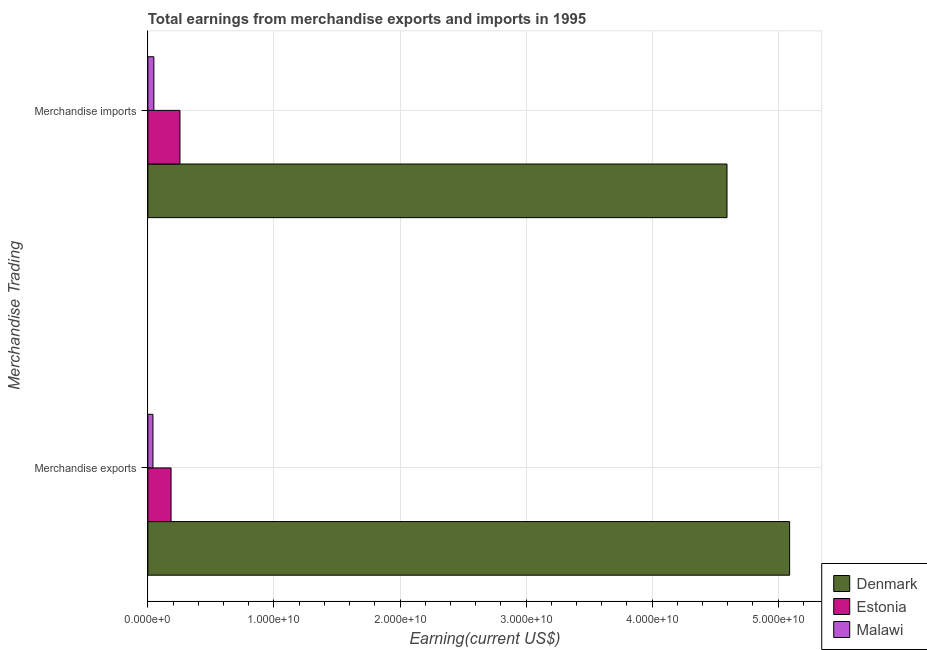How many different coloured bars are there?
Make the answer very short. 3. How many groups of bars are there?
Keep it short and to the point. 2. Are the number of bars per tick equal to the number of legend labels?
Keep it short and to the point. Yes. Are the number of bars on each tick of the Y-axis equal?
Offer a very short reply. Yes. How many bars are there on the 2nd tick from the bottom?
Offer a terse response. 3. What is the label of the 2nd group of bars from the top?
Ensure brevity in your answer.  Merchandise exports. What is the earnings from merchandise exports in Malawi?
Make the answer very short. 4.05e+08. Across all countries, what is the maximum earnings from merchandise imports?
Offer a terse response. 4.59e+1. Across all countries, what is the minimum earnings from merchandise exports?
Your response must be concise. 4.05e+08. In which country was the earnings from merchandise exports maximum?
Your answer should be compact. Denmark. In which country was the earnings from merchandise imports minimum?
Ensure brevity in your answer.  Malawi. What is the total earnings from merchandise exports in the graph?
Make the answer very short. 5.32e+1. What is the difference between the earnings from merchandise exports in Denmark and that in Estonia?
Your answer should be very brief. 4.91e+1. What is the difference between the earnings from merchandise imports in Denmark and the earnings from merchandise exports in Estonia?
Provide a short and direct response. 4.41e+1. What is the average earnings from merchandise imports per country?
Your answer should be very brief. 1.63e+1. What is the difference between the earnings from merchandise exports and earnings from merchandise imports in Estonia?
Provide a succinct answer. -7.06e+08. What is the ratio of the earnings from merchandise exports in Estonia to that in Denmark?
Keep it short and to the point. 0.04. What does the 2nd bar from the top in Merchandise exports represents?
Offer a terse response. Estonia. What does the 2nd bar from the bottom in Merchandise exports represents?
Keep it short and to the point. Estonia. Are all the bars in the graph horizontal?
Your answer should be very brief. Yes. What is the difference between two consecutive major ticks on the X-axis?
Your answer should be very brief. 1.00e+1. Are the values on the major ticks of X-axis written in scientific E-notation?
Your answer should be compact. Yes. Does the graph contain grids?
Your answer should be very brief. Yes. Where does the legend appear in the graph?
Make the answer very short. Bottom right. What is the title of the graph?
Offer a terse response. Total earnings from merchandise exports and imports in 1995. Does "Kazakhstan" appear as one of the legend labels in the graph?
Provide a short and direct response. No. What is the label or title of the X-axis?
Offer a very short reply. Earning(current US$). What is the label or title of the Y-axis?
Give a very brief answer. Merchandise Trading. What is the Earning(current US$) of Denmark in Merchandise exports?
Make the answer very short. 5.09e+1. What is the Earning(current US$) of Estonia in Merchandise exports?
Your response must be concise. 1.84e+09. What is the Earning(current US$) in Malawi in Merchandise exports?
Provide a short and direct response. 4.05e+08. What is the Earning(current US$) of Denmark in Merchandise imports?
Provide a short and direct response. 4.59e+1. What is the Earning(current US$) of Estonia in Merchandise imports?
Make the answer very short. 2.55e+09. What is the Earning(current US$) of Malawi in Merchandise imports?
Offer a very short reply. 4.75e+08. Across all Merchandise Trading, what is the maximum Earning(current US$) of Denmark?
Give a very brief answer. 5.09e+1. Across all Merchandise Trading, what is the maximum Earning(current US$) in Estonia?
Your answer should be very brief. 2.55e+09. Across all Merchandise Trading, what is the maximum Earning(current US$) of Malawi?
Give a very brief answer. 4.75e+08. Across all Merchandise Trading, what is the minimum Earning(current US$) of Denmark?
Your response must be concise. 4.59e+1. Across all Merchandise Trading, what is the minimum Earning(current US$) of Estonia?
Offer a very short reply. 1.84e+09. Across all Merchandise Trading, what is the minimum Earning(current US$) of Malawi?
Offer a very short reply. 4.05e+08. What is the total Earning(current US$) in Denmark in the graph?
Offer a terse response. 9.68e+1. What is the total Earning(current US$) of Estonia in the graph?
Keep it short and to the point. 4.39e+09. What is the total Earning(current US$) of Malawi in the graph?
Provide a succinct answer. 8.80e+08. What is the difference between the Earning(current US$) in Denmark in Merchandise exports and that in Merchandise imports?
Make the answer very short. 4.97e+09. What is the difference between the Earning(current US$) in Estonia in Merchandise exports and that in Merchandise imports?
Provide a succinct answer. -7.06e+08. What is the difference between the Earning(current US$) of Malawi in Merchandise exports and that in Merchandise imports?
Offer a very short reply. -7.00e+07. What is the difference between the Earning(current US$) of Denmark in Merchandise exports and the Earning(current US$) of Estonia in Merchandise imports?
Your answer should be very brief. 4.84e+1. What is the difference between the Earning(current US$) in Denmark in Merchandise exports and the Earning(current US$) in Malawi in Merchandise imports?
Ensure brevity in your answer.  5.04e+1. What is the difference between the Earning(current US$) of Estonia in Merchandise exports and the Earning(current US$) of Malawi in Merchandise imports?
Offer a terse response. 1.36e+09. What is the average Earning(current US$) of Denmark per Merchandise Trading?
Give a very brief answer. 4.84e+1. What is the average Earning(current US$) of Estonia per Merchandise Trading?
Your answer should be very brief. 2.19e+09. What is the average Earning(current US$) of Malawi per Merchandise Trading?
Provide a succinct answer. 4.40e+08. What is the difference between the Earning(current US$) in Denmark and Earning(current US$) in Estonia in Merchandise exports?
Make the answer very short. 4.91e+1. What is the difference between the Earning(current US$) in Denmark and Earning(current US$) in Malawi in Merchandise exports?
Keep it short and to the point. 5.05e+1. What is the difference between the Earning(current US$) of Estonia and Earning(current US$) of Malawi in Merchandise exports?
Give a very brief answer. 1.44e+09. What is the difference between the Earning(current US$) of Denmark and Earning(current US$) of Estonia in Merchandise imports?
Provide a short and direct response. 4.34e+1. What is the difference between the Earning(current US$) of Denmark and Earning(current US$) of Malawi in Merchandise imports?
Your answer should be compact. 4.55e+1. What is the difference between the Earning(current US$) of Estonia and Earning(current US$) of Malawi in Merchandise imports?
Provide a succinct answer. 2.07e+09. What is the ratio of the Earning(current US$) in Denmark in Merchandise exports to that in Merchandise imports?
Ensure brevity in your answer.  1.11. What is the ratio of the Earning(current US$) in Estonia in Merchandise exports to that in Merchandise imports?
Provide a succinct answer. 0.72. What is the ratio of the Earning(current US$) in Malawi in Merchandise exports to that in Merchandise imports?
Provide a succinct answer. 0.85. What is the difference between the highest and the second highest Earning(current US$) in Denmark?
Your answer should be very brief. 4.97e+09. What is the difference between the highest and the second highest Earning(current US$) in Estonia?
Provide a succinct answer. 7.06e+08. What is the difference between the highest and the second highest Earning(current US$) in Malawi?
Make the answer very short. 7.00e+07. What is the difference between the highest and the lowest Earning(current US$) of Denmark?
Keep it short and to the point. 4.97e+09. What is the difference between the highest and the lowest Earning(current US$) of Estonia?
Your answer should be very brief. 7.06e+08. What is the difference between the highest and the lowest Earning(current US$) of Malawi?
Give a very brief answer. 7.00e+07. 